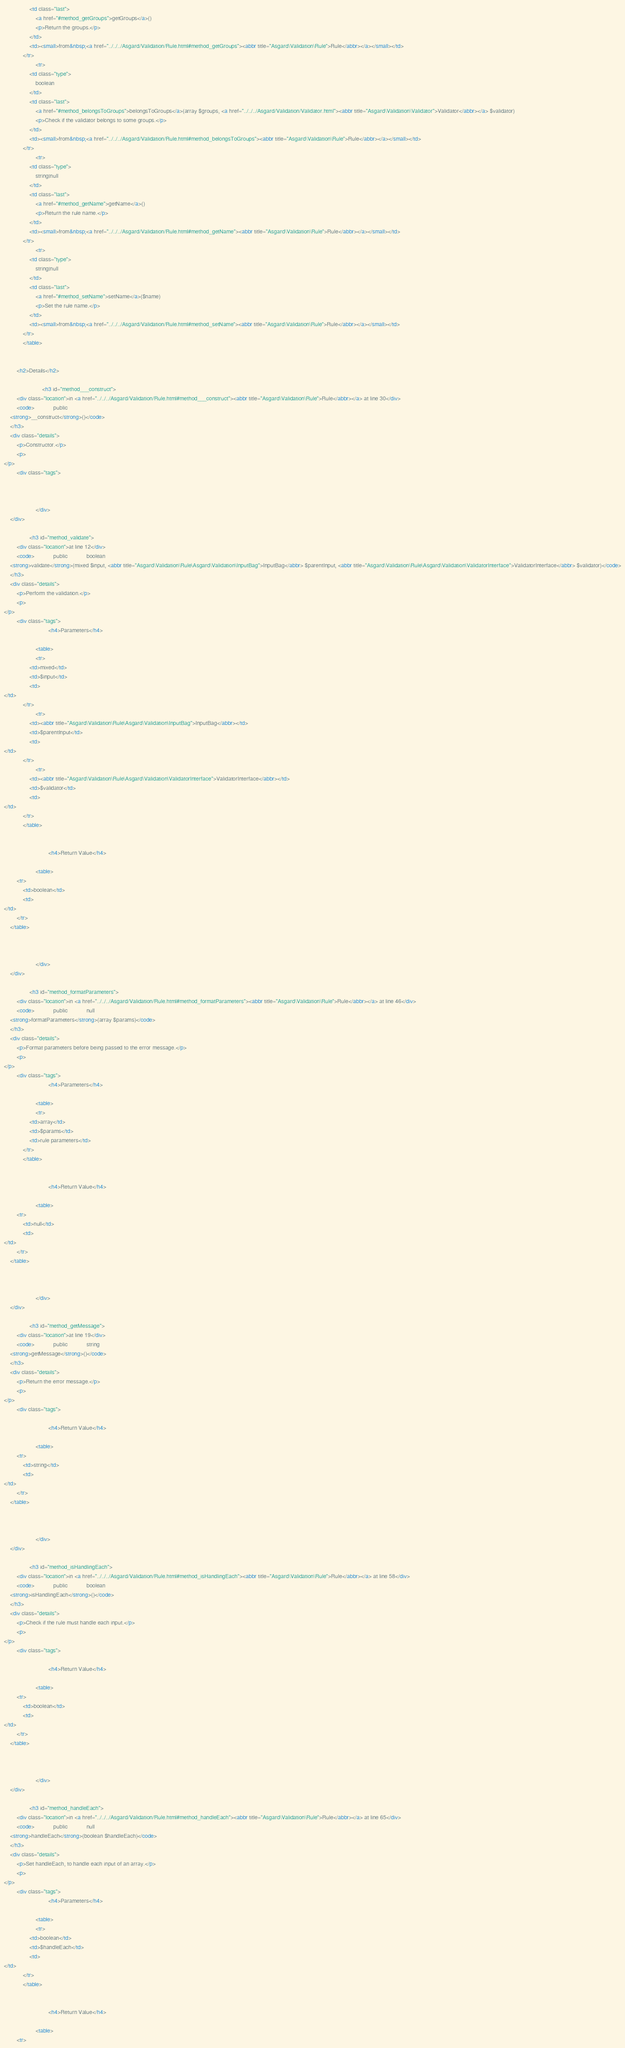Convert code to text. <code><loc_0><loc_0><loc_500><loc_500><_HTML_>                <td class="last">
                    <a href="#method_getGroups">getGroups</a>()
                    <p>Return the groups.</p>
                </td>
                <td><small>from&nbsp;<a href="../../../Asgard/Validation/Rule.html#method_getGroups"><abbr title="Asgard\Validation\Rule">Rule</abbr></a></small></td>
            </tr>
                    <tr>
                <td class="type">
                    boolean
                </td>
                <td class="last">
                    <a href="#method_belongsToGroups">belongsToGroups</a>(array $groups, <a href="../../../Asgard/Validation/Validator.html"><abbr title="Asgard\Validation\Validator">Validator</abbr></a> $validator)
                    <p>Check if the validator belongs to some groups.</p>
                </td>
                <td><small>from&nbsp;<a href="../../../Asgard/Validation/Rule.html#method_belongsToGroups"><abbr title="Asgard\Validation\Rule">Rule</abbr></a></small></td>
            </tr>
                    <tr>
                <td class="type">
                    string|null
                </td>
                <td class="last">
                    <a href="#method_getName">getName</a>()
                    <p>Return the rule name.</p>
                </td>
                <td><small>from&nbsp;<a href="../../../Asgard/Validation/Rule.html#method_getName"><abbr title="Asgard\Validation\Rule">Rule</abbr></a></small></td>
            </tr>
                    <tr>
                <td class="type">
                    string|null
                </td>
                <td class="last">
                    <a href="#method_setName">setName</a>($name)
                    <p>Set the rule name.</p>
                </td>
                <td><small>from&nbsp;<a href="../../../Asgard/Validation/Rule.html#method_setName"><abbr title="Asgard\Validation\Rule">Rule</abbr></a></small></td>
            </tr>
            </table>


        <h2>Details</h2>

                        <h3 id="method___construct">
        <div class="location">in <a href="../../../Asgard/Validation/Rule.html#method___construct"><abbr title="Asgard\Validation\Rule">Rule</abbr></a> at line 30</div>
        <code>            public            
    <strong>__construct</strong>()</code>
    </h3>
    <div class="details">
        <p>Constructor.</p>
        <p>
</p>
        <div class="tags">
            
            
            
                    </div>
    </div>

                <h3 id="method_validate">
        <div class="location">at line 12</div>
        <code>            public            boolean
    <strong>validate</strong>(mixed $input, <abbr title="Asgard\Validation\Rule\Asgard\Validation\InputBag">InputBag</abbr> $parentInput, <abbr title="Asgard\Validation\Rule\Asgard\Validation\ValidatorInterface">ValidatorInterface</abbr> $validator)</code>
    </h3>
    <div class="details">
        <p>Perform the validation.</p>
        <p>
</p>
        <div class="tags">
                            <h4>Parameters</h4>

                    <table>
                    <tr>
                <td>mixed</td>
                <td>$input</td>
                <td>
</td>
            </tr>
                    <tr>
                <td><abbr title="Asgard\Validation\Rule\Asgard\Validation\InputBag">InputBag</abbr></td>
                <td>$parentInput</td>
                <td>
</td>
            </tr>
                    <tr>
                <td><abbr title="Asgard\Validation\Rule\Asgard\Validation\ValidatorInterface">ValidatorInterface</abbr></td>
                <td>$validator</td>
                <td>
</td>
            </tr>
            </table>

            
                            <h4>Return Value</h4>

                    <table>
        <tr>
            <td>boolean</td>
            <td>
</td>
        </tr>
    </table>

            
            
                    </div>
    </div>

                <h3 id="method_formatParameters">
        <div class="location">in <a href="../../../Asgard/Validation/Rule.html#method_formatParameters"><abbr title="Asgard\Validation\Rule">Rule</abbr></a> at line 46</div>
        <code>            public            null
    <strong>formatParameters</strong>(array $params)</code>
    </h3>
    <div class="details">
        <p>Format parameters before being passed to the error message.</p>
        <p>
</p>
        <div class="tags">
                            <h4>Parameters</h4>

                    <table>
                    <tr>
                <td>array</td>
                <td>$params</td>
                <td>rule parameters</td>
            </tr>
            </table>

            
                            <h4>Return Value</h4>

                    <table>
        <tr>
            <td>null</td>
            <td>
</td>
        </tr>
    </table>

            
            
                    </div>
    </div>

                <h3 id="method_getMessage">
        <div class="location">at line 19</div>
        <code>            public            string
    <strong>getMessage</strong>()</code>
    </h3>
    <div class="details">
        <p>Return the error message.</p>
        <p>
</p>
        <div class="tags">
            
                            <h4>Return Value</h4>

                    <table>
        <tr>
            <td>string</td>
            <td>
</td>
        </tr>
    </table>

            
            
                    </div>
    </div>

                <h3 id="method_isHandlingEach">
        <div class="location">in <a href="../../../Asgard/Validation/Rule.html#method_isHandlingEach"><abbr title="Asgard\Validation\Rule">Rule</abbr></a> at line 58</div>
        <code>            public            boolean
    <strong>isHandlingEach</strong>()</code>
    </h3>
    <div class="details">
        <p>Check if the rule must handle each input.</p>
        <p>
</p>
        <div class="tags">
            
                            <h4>Return Value</h4>

                    <table>
        <tr>
            <td>boolean</td>
            <td>
</td>
        </tr>
    </table>

            
            
                    </div>
    </div>

                <h3 id="method_handleEach">
        <div class="location">in <a href="../../../Asgard/Validation/Rule.html#method_handleEach"><abbr title="Asgard\Validation\Rule">Rule</abbr></a> at line 65</div>
        <code>            public            null
    <strong>handleEach</strong>(boolean $handleEach)</code>
    </h3>
    <div class="details">
        <p>Set handleEach, to handle each input of an array.</p>
        <p>
</p>
        <div class="tags">
                            <h4>Parameters</h4>

                    <table>
                    <tr>
                <td>boolean</td>
                <td>$handleEach</td>
                <td>
</td>
            </tr>
            </table>

            
                            <h4>Return Value</h4>

                    <table>
        <tr></code> 